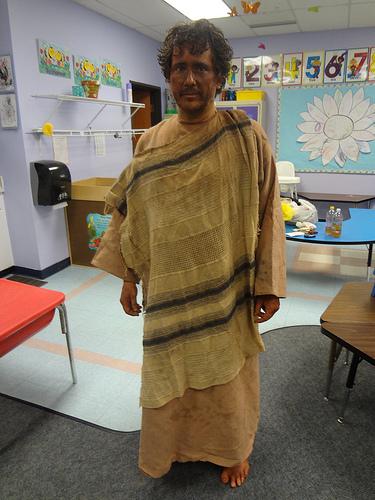<image>
Is the table on the man? No. The table is not positioned on the man. They may be near each other, but the table is not supported by or resting on top of the man. 